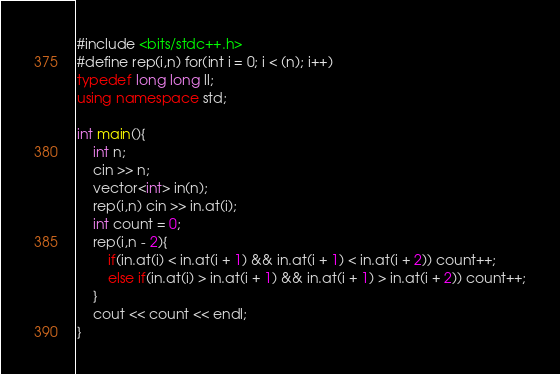Convert code to text. <code><loc_0><loc_0><loc_500><loc_500><_C++_>#include <bits/stdc++.h>
#define rep(i,n) for(int i = 0; i < (n); i++)
typedef long long ll;
using namespace std;

int main(){
    int n;
    cin >> n;
    vector<int> in(n);
    rep(i,n) cin >> in.at(i);
    int count = 0;
    rep(i,n - 2){
        if(in.at(i) < in.at(i + 1) && in.at(i + 1) < in.at(i + 2)) count++;
        else if(in.at(i) > in.at(i + 1) && in.at(i + 1) > in.at(i + 2)) count++;
    }
    cout << count << endl;
}
</code> 